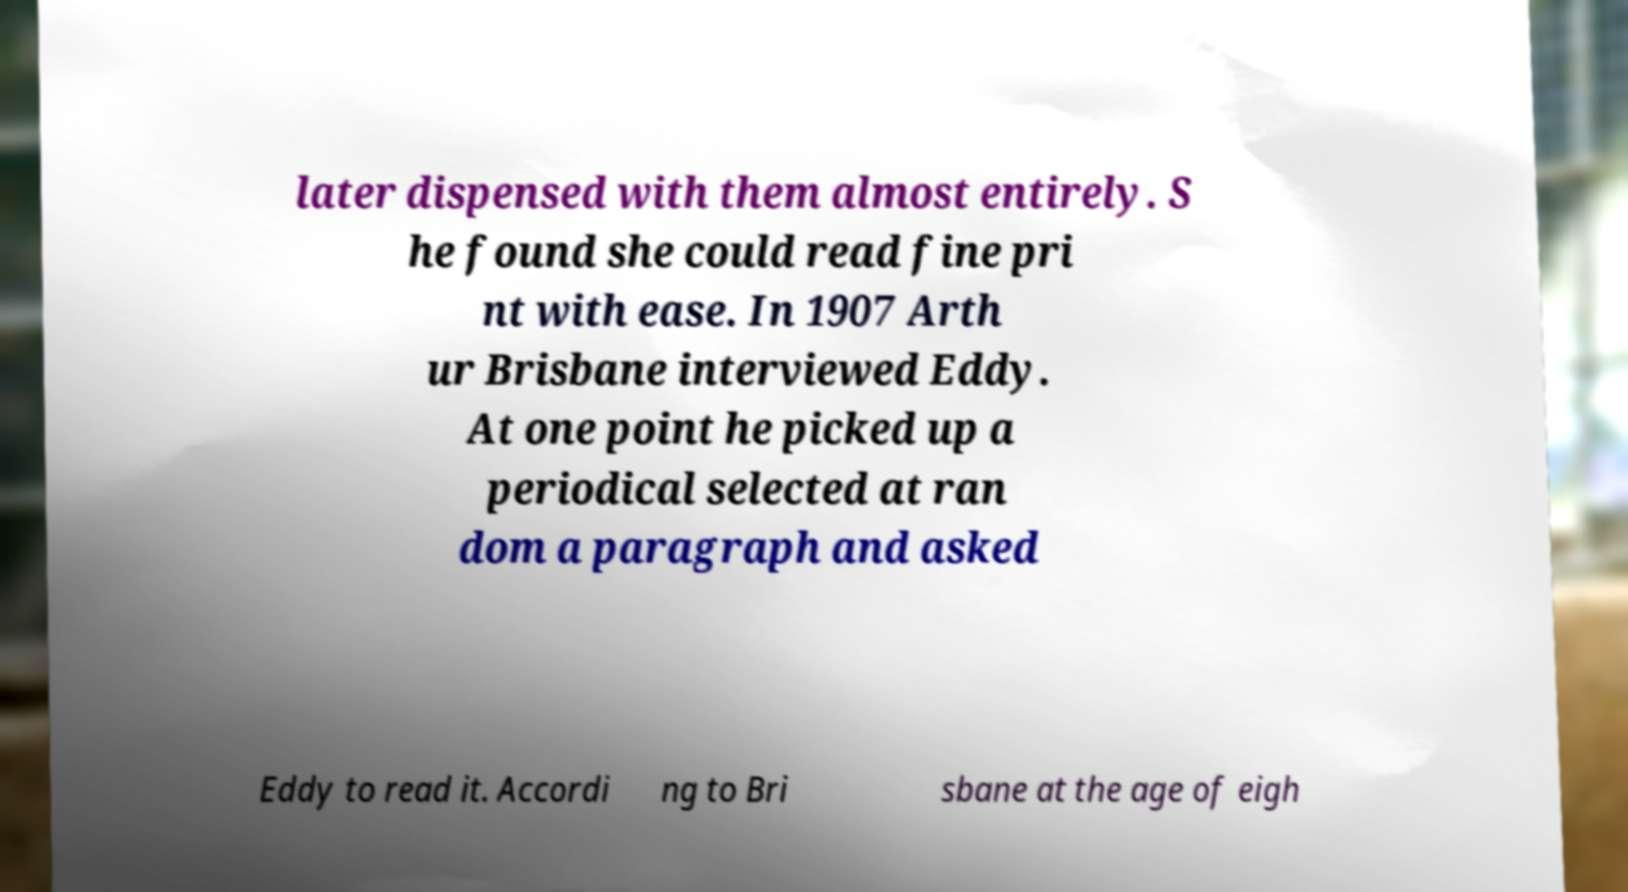Could you extract and type out the text from this image? later dispensed with them almost entirely. S he found she could read fine pri nt with ease. In 1907 Arth ur Brisbane interviewed Eddy. At one point he picked up a periodical selected at ran dom a paragraph and asked Eddy to read it. Accordi ng to Bri sbane at the age of eigh 